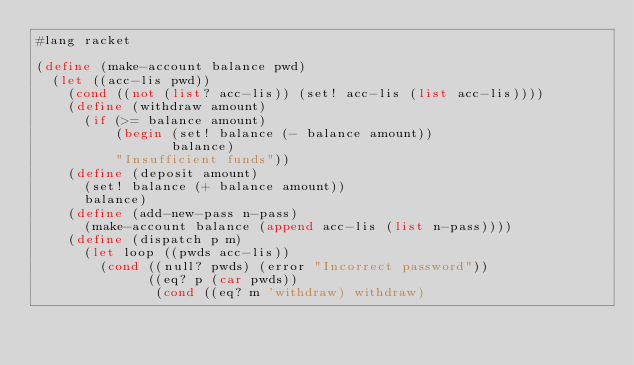<code> <loc_0><loc_0><loc_500><loc_500><_Scheme_>#lang racket

(define (make-account balance pwd)
  (let ((acc-lis pwd))
    (cond ((not (list? acc-lis)) (set! acc-lis (list acc-lis))))
    (define (withdraw amount)
      (if (>= balance amount)
          (begin (set! balance (- balance amount))
                 balance)
          "Insufficient funds"))
    (define (deposit amount)
      (set! balance (+ balance amount))
      balance)
    (define (add-new-pass n-pass)
      (make-account balance (append acc-lis (list n-pass))))
    (define (dispatch p m)
      (let loop ((pwds acc-lis))
        (cond ((null? pwds) (error "Incorrect password"))
              ((eq? p (car pwds))
               (cond ((eq? m 'withdraw) withdraw)</code> 